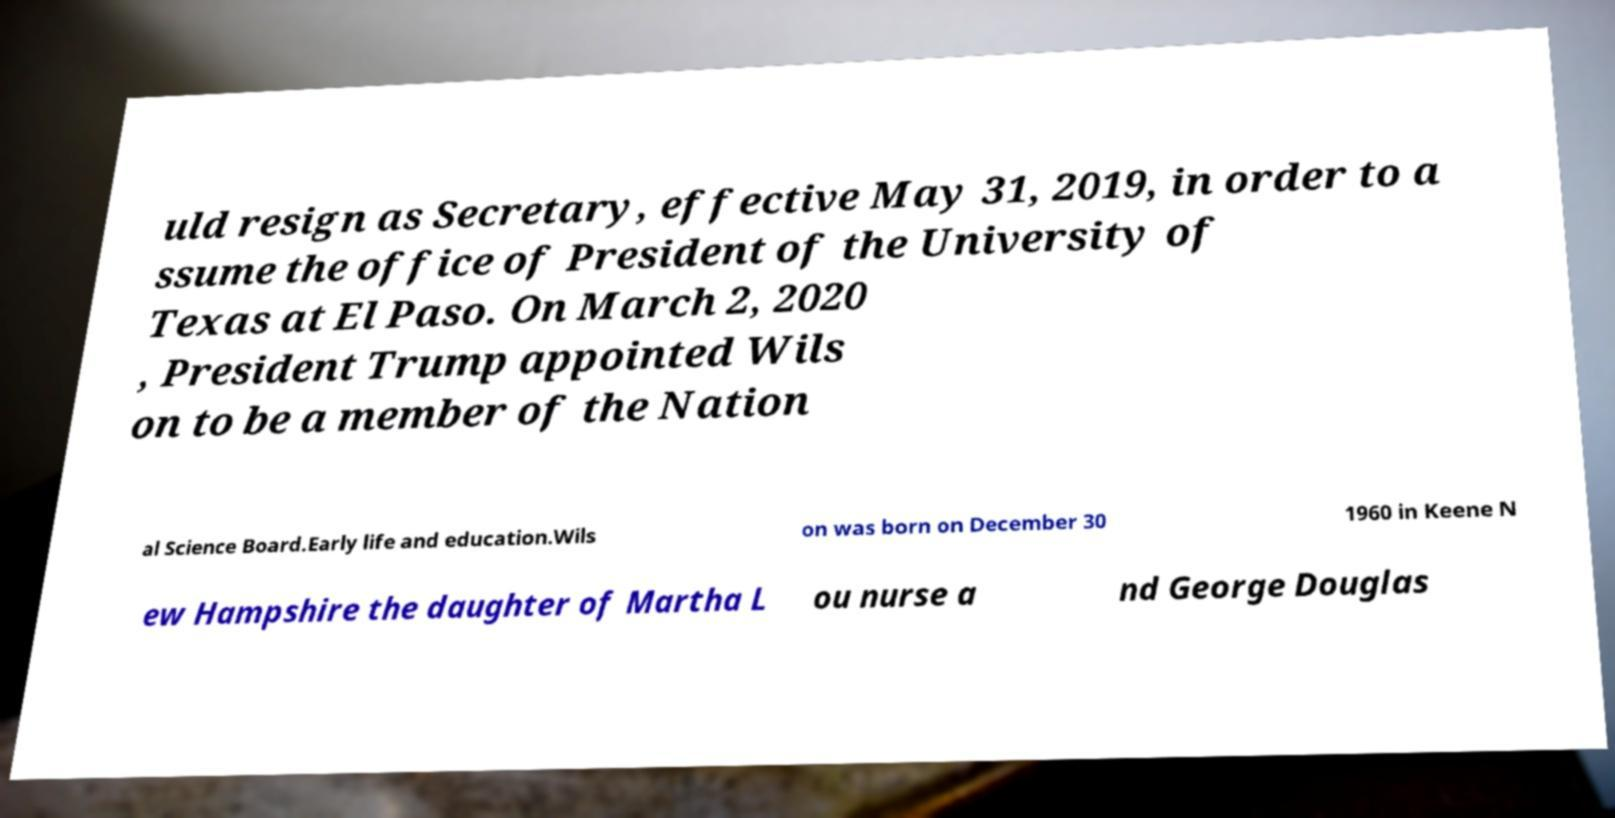Can you accurately transcribe the text from the provided image for me? uld resign as Secretary, effective May 31, 2019, in order to a ssume the office of President of the University of Texas at El Paso. On March 2, 2020 , President Trump appointed Wils on to be a member of the Nation al Science Board.Early life and education.Wils on was born on December 30 1960 in Keene N ew Hampshire the daughter of Martha L ou nurse a nd George Douglas 